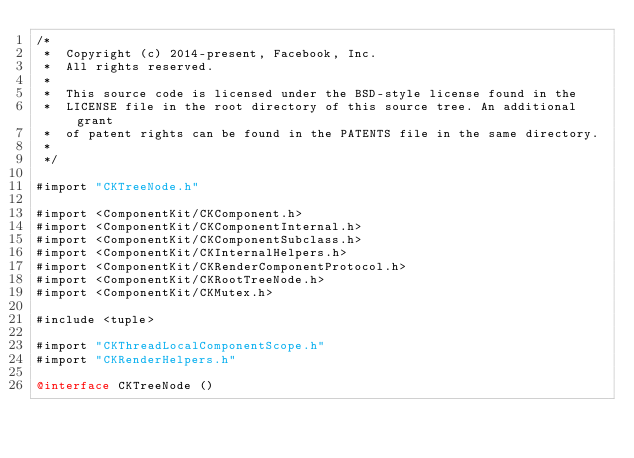<code> <loc_0><loc_0><loc_500><loc_500><_ObjectiveC_>/*
 *  Copyright (c) 2014-present, Facebook, Inc.
 *  All rights reserved.
 *
 *  This source code is licensed under the BSD-style license found in the
 *  LICENSE file in the root directory of this source tree. An additional grant
 *  of patent rights can be found in the PATENTS file in the same directory.
 *
 */

#import "CKTreeNode.h"

#import <ComponentKit/CKComponent.h>
#import <ComponentKit/CKComponentInternal.h>
#import <ComponentKit/CKComponentSubclass.h>
#import <ComponentKit/CKInternalHelpers.h>
#import <ComponentKit/CKRenderComponentProtocol.h>
#import <ComponentKit/CKRootTreeNode.h>
#import <ComponentKit/CKMutex.h>

#include <tuple>

#import "CKThreadLocalComponentScope.h"
#import "CKRenderHelpers.h"

@interface CKTreeNode ()</code> 